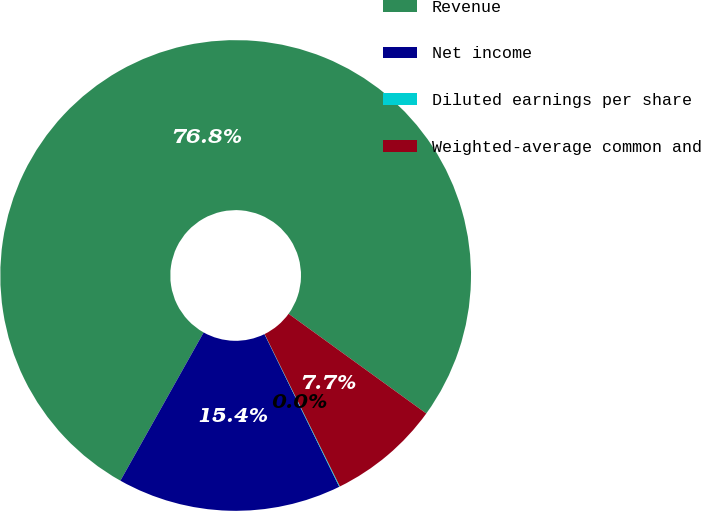<chart> <loc_0><loc_0><loc_500><loc_500><pie_chart><fcel>Revenue<fcel>Net income<fcel>Diluted earnings per share<fcel>Weighted-average common and<nl><fcel>76.83%<fcel>15.4%<fcel>0.05%<fcel>7.72%<nl></chart> 